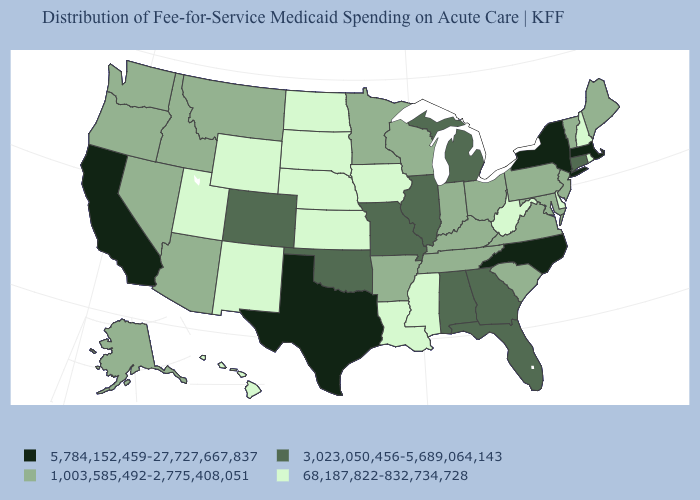Among the states that border Nevada , which have the lowest value?
Keep it brief. Utah. What is the lowest value in the USA?
Answer briefly. 68,187,822-832,734,728. Among the states that border Montana , which have the highest value?
Short answer required. Idaho. Does the map have missing data?
Write a very short answer. No. What is the value of North Carolina?
Keep it brief. 5,784,152,459-27,727,667,837. Among the states that border New York , which have the lowest value?
Answer briefly. New Jersey, Pennsylvania, Vermont. Does Montana have a higher value than South Dakota?
Write a very short answer. Yes. Among the states that border Indiana , which have the highest value?
Answer briefly. Illinois, Michigan. Name the states that have a value in the range 1,003,585,492-2,775,408,051?
Write a very short answer. Alaska, Arizona, Arkansas, Idaho, Indiana, Kentucky, Maine, Maryland, Minnesota, Montana, Nevada, New Jersey, Ohio, Oregon, Pennsylvania, South Carolina, Tennessee, Vermont, Virginia, Washington, Wisconsin. Among the states that border Delaware , which have the highest value?
Answer briefly. Maryland, New Jersey, Pennsylvania. Name the states that have a value in the range 68,187,822-832,734,728?
Quick response, please. Delaware, Hawaii, Iowa, Kansas, Louisiana, Mississippi, Nebraska, New Hampshire, New Mexico, North Dakota, Rhode Island, South Dakota, Utah, West Virginia, Wyoming. Name the states that have a value in the range 68,187,822-832,734,728?
Write a very short answer. Delaware, Hawaii, Iowa, Kansas, Louisiana, Mississippi, Nebraska, New Hampshire, New Mexico, North Dakota, Rhode Island, South Dakota, Utah, West Virginia, Wyoming. What is the value of Massachusetts?
Write a very short answer. 5,784,152,459-27,727,667,837. Does Arkansas have the lowest value in the USA?
Answer briefly. No. Does Kansas have the lowest value in the MidWest?
Keep it brief. Yes. 